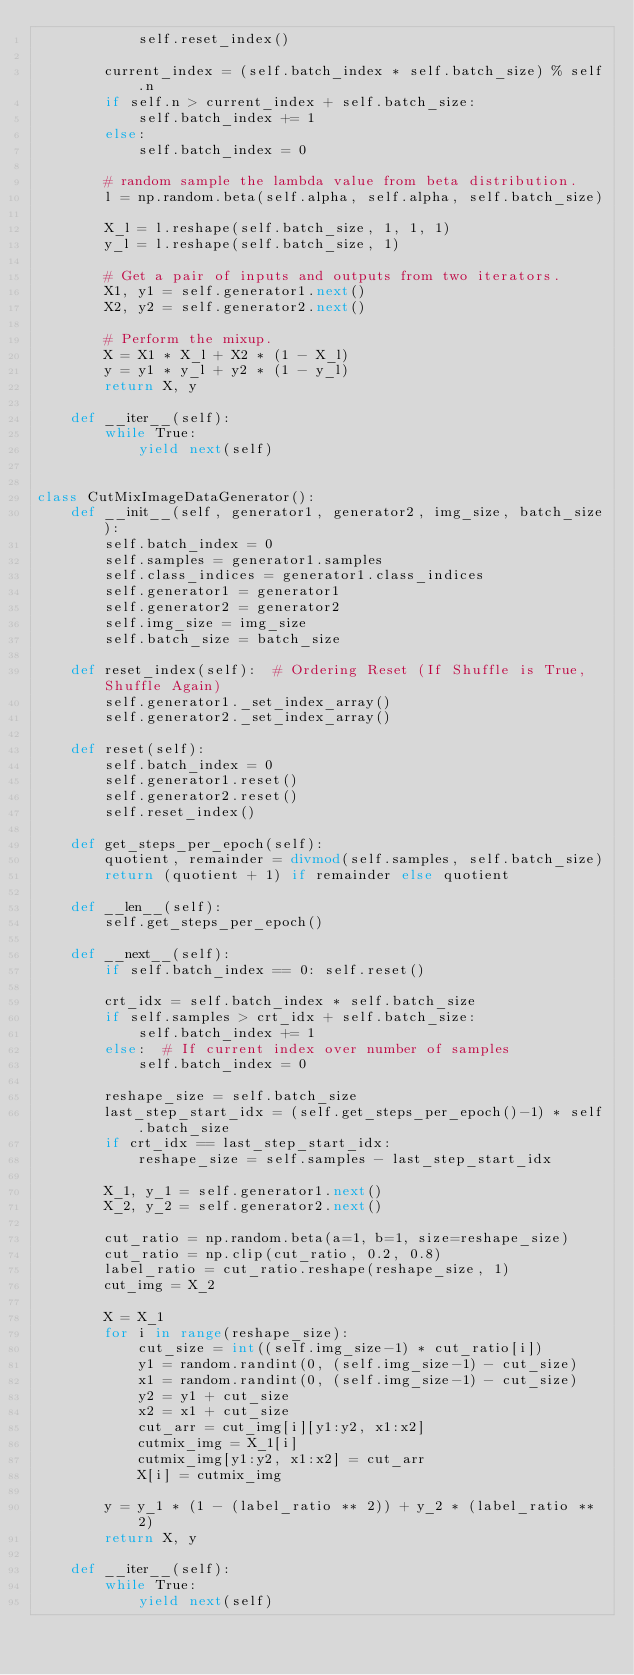<code> <loc_0><loc_0><loc_500><loc_500><_Python_>            self.reset_index()

        current_index = (self.batch_index * self.batch_size) % self.n
        if self.n > current_index + self.batch_size:
            self.batch_index += 1
        else:
            self.batch_index = 0

        # random sample the lambda value from beta distribution.
        l = np.random.beta(self.alpha, self.alpha, self.batch_size)

        X_l = l.reshape(self.batch_size, 1, 1, 1)
        y_l = l.reshape(self.batch_size, 1)

        # Get a pair of inputs and outputs from two iterators.
        X1, y1 = self.generator1.next()
        X2, y2 = self.generator2.next()

        # Perform the mixup.
        X = X1 * X_l + X2 * (1 - X_l)
        y = y1 * y_l + y2 * (1 - y_l)
        return X, y

    def __iter__(self):
        while True:
            yield next(self)


class CutMixImageDataGenerator():
    def __init__(self, generator1, generator2, img_size, batch_size):
        self.batch_index = 0
        self.samples = generator1.samples
        self.class_indices = generator1.class_indices
        self.generator1 = generator1
        self.generator2 = generator2
        self.img_size = img_size
        self.batch_size = batch_size

    def reset_index(self):  # Ordering Reset (If Shuffle is True, Shuffle Again)
        self.generator1._set_index_array()
        self.generator2._set_index_array()

    def reset(self):
        self.batch_index = 0
        self.generator1.reset()
        self.generator2.reset()
        self.reset_index()

    def get_steps_per_epoch(self):
        quotient, remainder = divmod(self.samples, self.batch_size)
        return (quotient + 1) if remainder else quotient
    
    def __len__(self):
        self.get_steps_per_epoch()

    def __next__(self):
        if self.batch_index == 0: self.reset()

        crt_idx = self.batch_index * self.batch_size
        if self.samples > crt_idx + self.batch_size:
            self.batch_index += 1
        else:  # If current index over number of samples
            self.batch_index = 0

        reshape_size = self.batch_size
        last_step_start_idx = (self.get_steps_per_epoch()-1) * self.batch_size
        if crt_idx == last_step_start_idx:
            reshape_size = self.samples - last_step_start_idx
            
        X_1, y_1 = self.generator1.next()
        X_2, y_2 = self.generator2.next()
        
        cut_ratio = np.random.beta(a=1, b=1, size=reshape_size)
        cut_ratio = np.clip(cut_ratio, 0.2, 0.8)
        label_ratio = cut_ratio.reshape(reshape_size, 1)
        cut_img = X_2

        X = X_1
        for i in range(reshape_size):
            cut_size = int((self.img_size-1) * cut_ratio[i])
            y1 = random.randint(0, (self.img_size-1) - cut_size)
            x1 = random.randint(0, (self.img_size-1) - cut_size)
            y2 = y1 + cut_size
            x2 = x1 + cut_size
            cut_arr = cut_img[i][y1:y2, x1:x2]
            cutmix_img = X_1[i]
            cutmix_img[y1:y2, x1:x2] = cut_arr
            X[i] = cutmix_img
            
        y = y_1 * (1 - (label_ratio ** 2)) + y_2 * (label_ratio ** 2)
        return X, y

    def __iter__(self):
        while True:
            yield next(self)</code> 